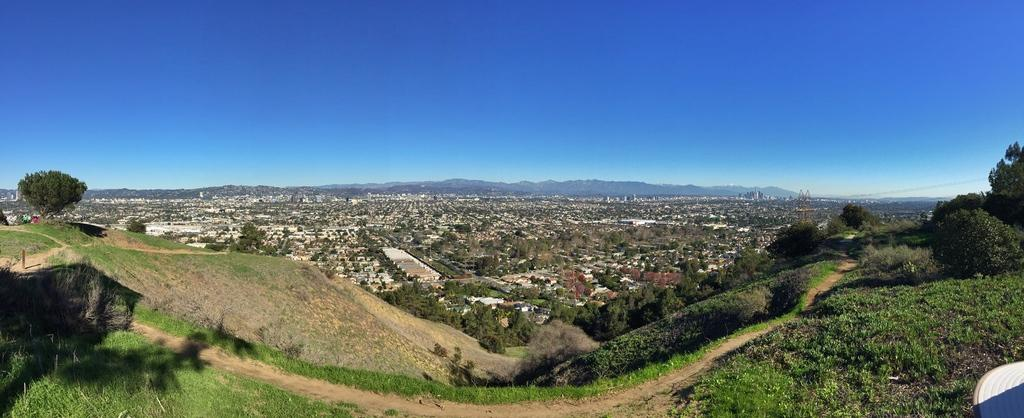What type of structures can be seen in the image? There are houses in the image. What natural elements are present in the image? There are trees and green grass in the image. What type of landscape feature is visible in the image? There are mountains in the image. What is the color of the sky in the image? The sky is blue in color. Can you see a pencil in the pocket of someone in the image? There is no mention of a pencil or a pocket in the image, so we cannot determine if a pencil is present in someone's pocket. 